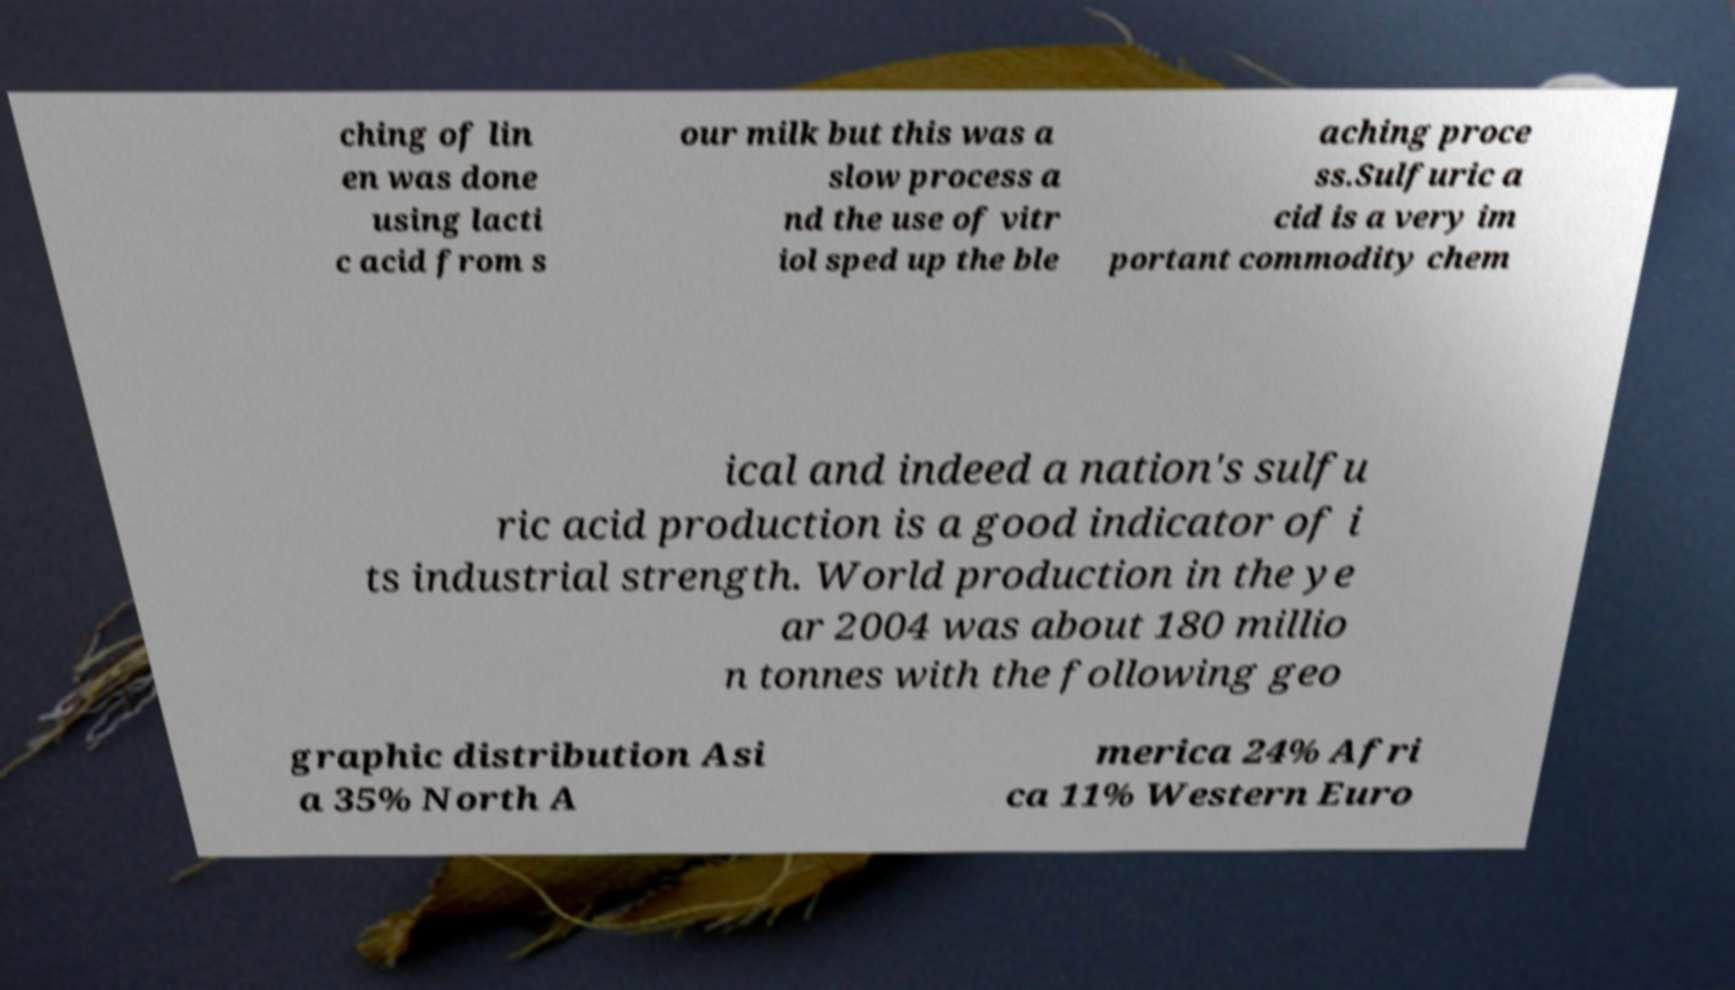Please read and relay the text visible in this image. What does it say? ching of lin en was done using lacti c acid from s our milk but this was a slow process a nd the use of vitr iol sped up the ble aching proce ss.Sulfuric a cid is a very im portant commodity chem ical and indeed a nation's sulfu ric acid production is a good indicator of i ts industrial strength. World production in the ye ar 2004 was about 180 millio n tonnes with the following geo graphic distribution Asi a 35% North A merica 24% Afri ca 11% Western Euro 